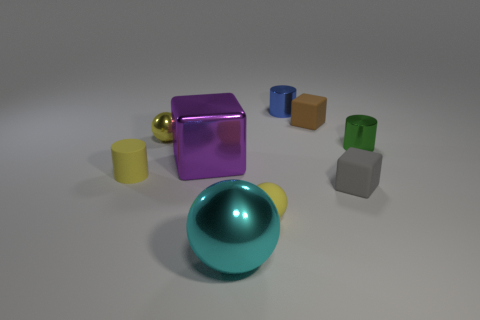There is a small cylinder that is made of the same material as the brown object; what color is it?
Give a very brief answer. Yellow. Is there anything else that has the same shape as the small gray rubber object?
Your answer should be very brief. Yes. There is a big metallic thing that is left of the big ball; is it the same color as the tiny matte thing behind the small yellow rubber cylinder?
Your answer should be compact. No. Is the number of small yellow rubber cylinders on the right side of the metallic cube less than the number of blue metallic things that are left of the big cyan shiny object?
Ensure brevity in your answer.  No. What is the shape of the big shiny object in front of the tiny gray thing?
Keep it short and to the point. Sphere. There is another tiny ball that is the same color as the rubber sphere; what is it made of?
Offer a terse response. Metal. How many other objects are the same material as the tiny gray thing?
Give a very brief answer. 3. Is the shape of the tiny brown matte thing the same as the big object that is in front of the yellow rubber ball?
Your answer should be very brief. No. There is a big purple thing that is made of the same material as the big cyan thing; what is its shape?
Offer a terse response. Cube. Is the number of blue metal cylinders that are to the left of the big cyan thing greater than the number of small blocks left of the tiny brown matte thing?
Your response must be concise. No. 